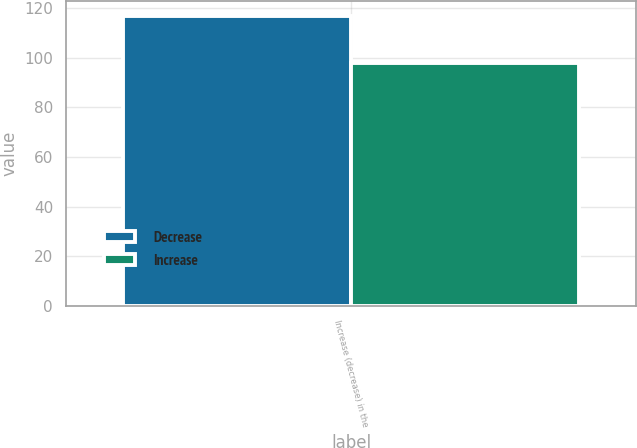Convert chart to OTSL. <chart><loc_0><loc_0><loc_500><loc_500><stacked_bar_chart><ecel><fcel>Increase (decrease) in the<nl><fcel>Decrease<fcel>117<nl><fcel>Increase<fcel>98<nl></chart> 